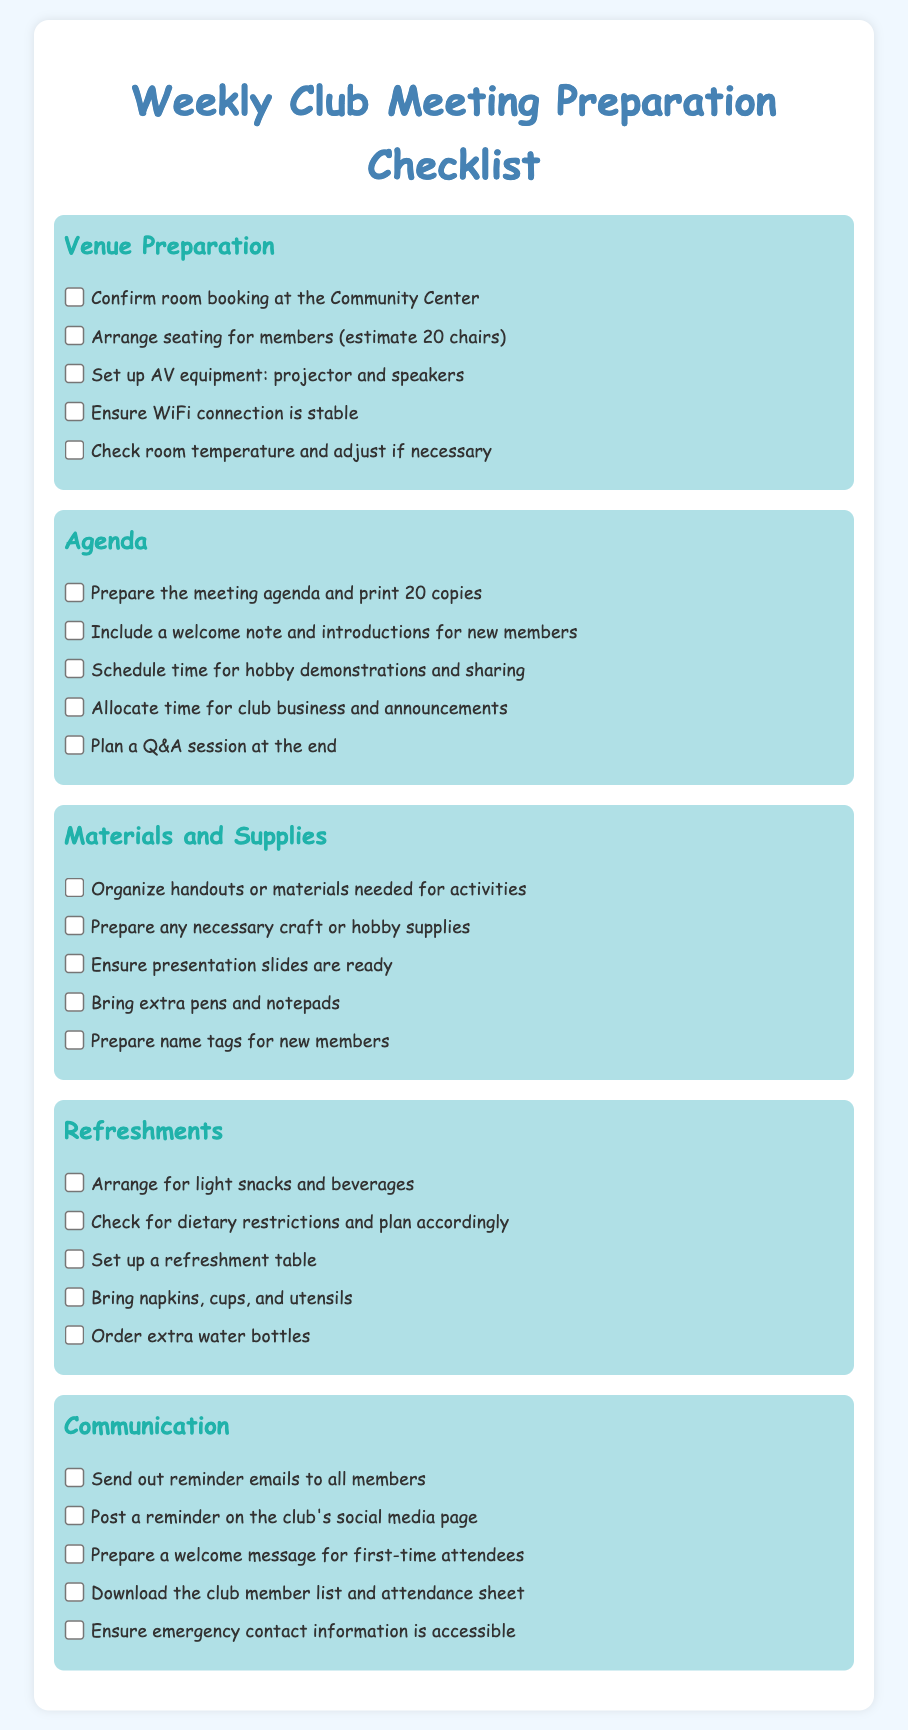What is the title of the checklist? The title of the checklist is presented prominently at the top of the document, indicating its purpose for club meeting preparation.
Answer: Weekly Club Meeting Preparation Checklist How many chairs should be estimated for members? The document specifies the estimated number of chairs needed for members during the meeting.
Answer: 20 chairs What item is needed to ensure a stable WiFi connection? "Ensure WiFi connection is stable" is stated as one of the tasks in the Venue Preparation section of the checklist.
Answer: WiFi connection What should be included in the meeting agenda according to the checklist? The checklist mentions details regarding what items should be included, such as a welcome note and time for demonstrations.
Answer: Welcome note and introductions for new members What types of refreshments are mentioned to be arranged? The checklist outlines the need for specific items regarding refreshments during the meeting.
Answer: Light snacks and beverages What should be done in terms of communication with club members? Sending out reminder emails to all members is suggested in the Communication section.
Answer: Send out reminder emails How many copies of the agenda should be printed? The document clearly states how many copies of the agenda need to be prepared and printed.
Answer: 20 copies What is the purpose of the Q&A session in the agenda? It is meant to provide time for members to ask questions at the end of the meeting, enhancing engagement.
Answer: Plan a Q&A session at the end What should be prepared for new members? The checklist mentions specific items that need to be ready for new members attending the club meeting.
Answer: Name tags for new members 